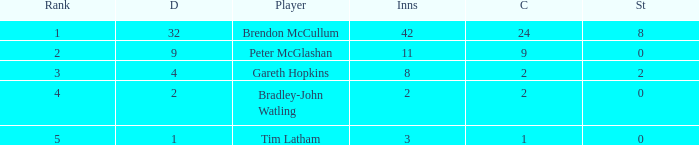What is the number of stumpings tim latham achieved? 0.0. 